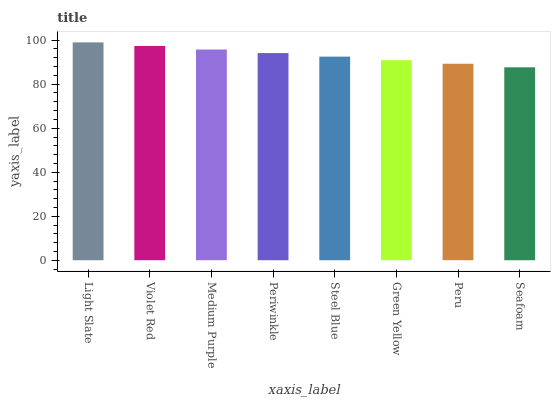Is Seafoam the minimum?
Answer yes or no. Yes. Is Light Slate the maximum?
Answer yes or no. Yes. Is Violet Red the minimum?
Answer yes or no. No. Is Violet Red the maximum?
Answer yes or no. No. Is Light Slate greater than Violet Red?
Answer yes or no. Yes. Is Violet Red less than Light Slate?
Answer yes or no. Yes. Is Violet Red greater than Light Slate?
Answer yes or no. No. Is Light Slate less than Violet Red?
Answer yes or no. No. Is Periwinkle the high median?
Answer yes or no. Yes. Is Steel Blue the low median?
Answer yes or no. Yes. Is Peru the high median?
Answer yes or no. No. Is Green Yellow the low median?
Answer yes or no. No. 